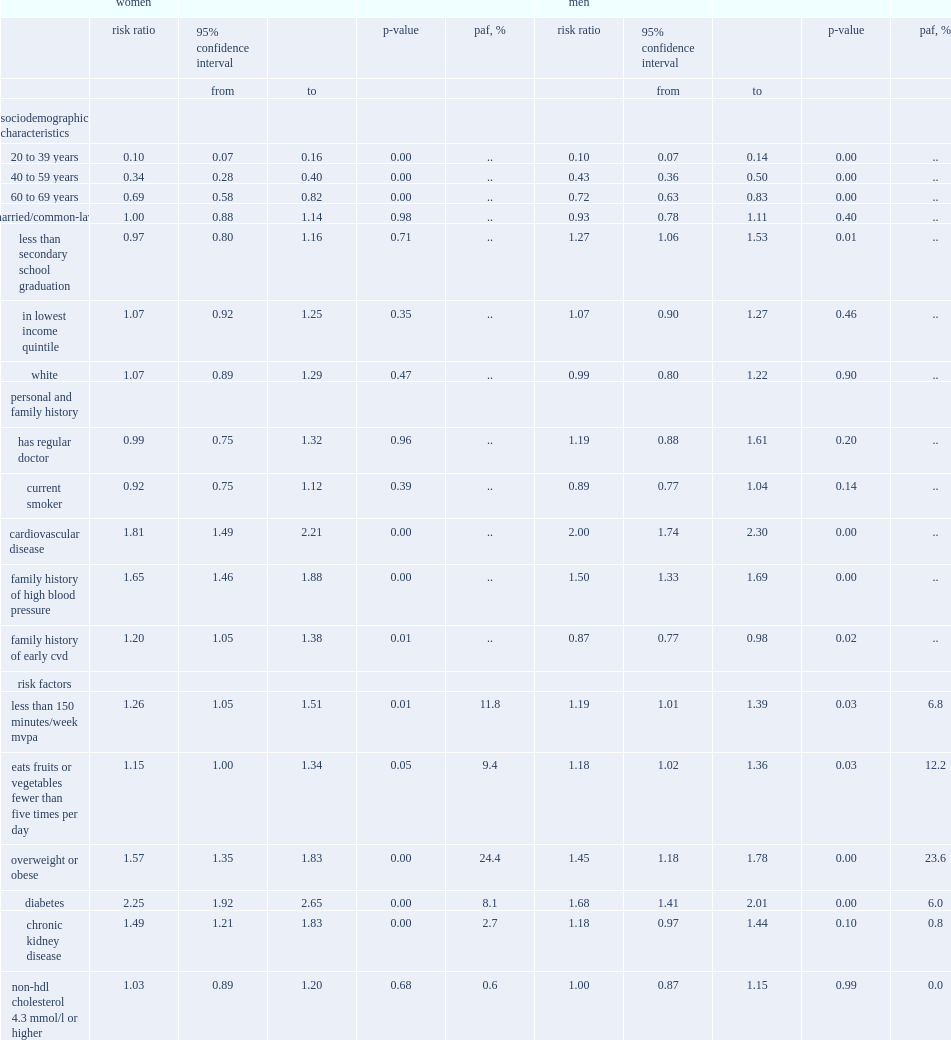What were the five candidate risk factors that were significantly associated with an increased risk of hypertension among women aged 20 to 79? Less than 150 minutes/week mvpa eats fruits or vegetables fewer than five times per day overweight or obese diabetes chronic kidney disease. Among men aged 20 to 79, what were the risk factors that were significantly associated with an increased risk of hypertension? Less than 150 minutes/week mvpa eats fruits or vegetables fewer than five times per day overweight or obese diabetes. Can you parse all the data within this table? {'header': ['', 'women', '', '', '', '', 'men', '', '', '', ''], 'rows': [['', 'risk ratio', '95% confidence interval', '', 'p-value', 'paf, %', 'risk ratio', '95% confidence interval', '', 'p-value', 'paf, %'], ['', '', 'from', 'to', '', '', '', 'from', 'to', '', ''], ['sociodemographic characteristics', '', '', '', '', '', '', '', '', '', ''], ['20 to 39 years', '0.10', '0.07', '0.16', '0.00', '..', '0.10', '0.07', '0.14', '0.00', '..'], ['40 to 59 years', '0.34', '0.28', '0.40', '0.00', '..', '0.43', '0.36', '0.50', '0.00', '..'], ['60 to 69 years', '0.69', '0.58', '0.82', '0.00', '..', '0.72', '0.63', '0.83', '0.00', '..'], ['married/common-law', '1.00', '0.88', '1.14', '0.98', '..', '0.93', '0.78', '1.11', '0.40', '..'], ['less than secondary school graduation', '0.97', '0.80', '1.16', '0.71', '..', '1.27', '1.06', '1.53', '0.01', '..'], ['in lowest income quintile', '1.07', '0.92', '1.25', '0.35', '..', '1.07', '0.90', '1.27', '0.46', '..'], ['white', '1.07', '0.89', '1.29', '0.47', '..', '0.99', '0.80', '1.22', '0.90', '..'], ['personal and family history', '', '', '', '', '', '', '', '', '', ''], ['has regular doctor', '0.99', '0.75', '1.32', '0.96', '..', '1.19', '0.88', '1.61', '0.20', '..'], ['current smoker', '0.92', '0.75', '1.12', '0.39', '..', '0.89', '0.77', '1.04', '0.14', '..'], ['cardiovascular disease', '1.81', '1.49', '2.21', '0.00', '..', '2.00', '1.74', '2.30', '0.00', '..'], ['family history of high blood pressure', '1.65', '1.46', '1.88', '0.00', '..', '1.50', '1.33', '1.69', '0.00', '..'], ['family history of early cvd', '1.20', '1.05', '1.38', '0.01', '..', '0.87', '0.77', '0.98', '0.02', '..'], ['risk factors', '', '', '', '', '', '', '', '', '', ''], ['less than 150 minutes/week mvpa', '1.26', '1.05', '1.51', '0.01', '11.8', '1.19', '1.01', '1.39', '0.03', '6.8'], ['eats fruits or vegetables fewer than five times per day', '1.15', '1.00', '1.34', '0.05', '9.4', '1.18', '1.02', '1.36', '0.03', '12.2'], ['overweight or obese', '1.57', '1.35', '1.83', '0.00', '24.4', '1.45', '1.18', '1.78', '0.00', '23.6'], ['diabetes', '2.25', '1.92', '2.65', '0.00', '8.1', '1.68', '1.41', '2.01', '0.00', '6.0'], ['chronic kidney disease', '1.49', '1.21', '1.83', '0.00', '2.7', '1.18', '0.97', '1.44', '0.10', '0.8'], ['non-hdl cholesterol 4.3 mmol/l or higher', '1.03', '0.89', '1.20', '0.68', '0.6', '1.00', '0.87', '1.15', '0.99', '0.0']]} 